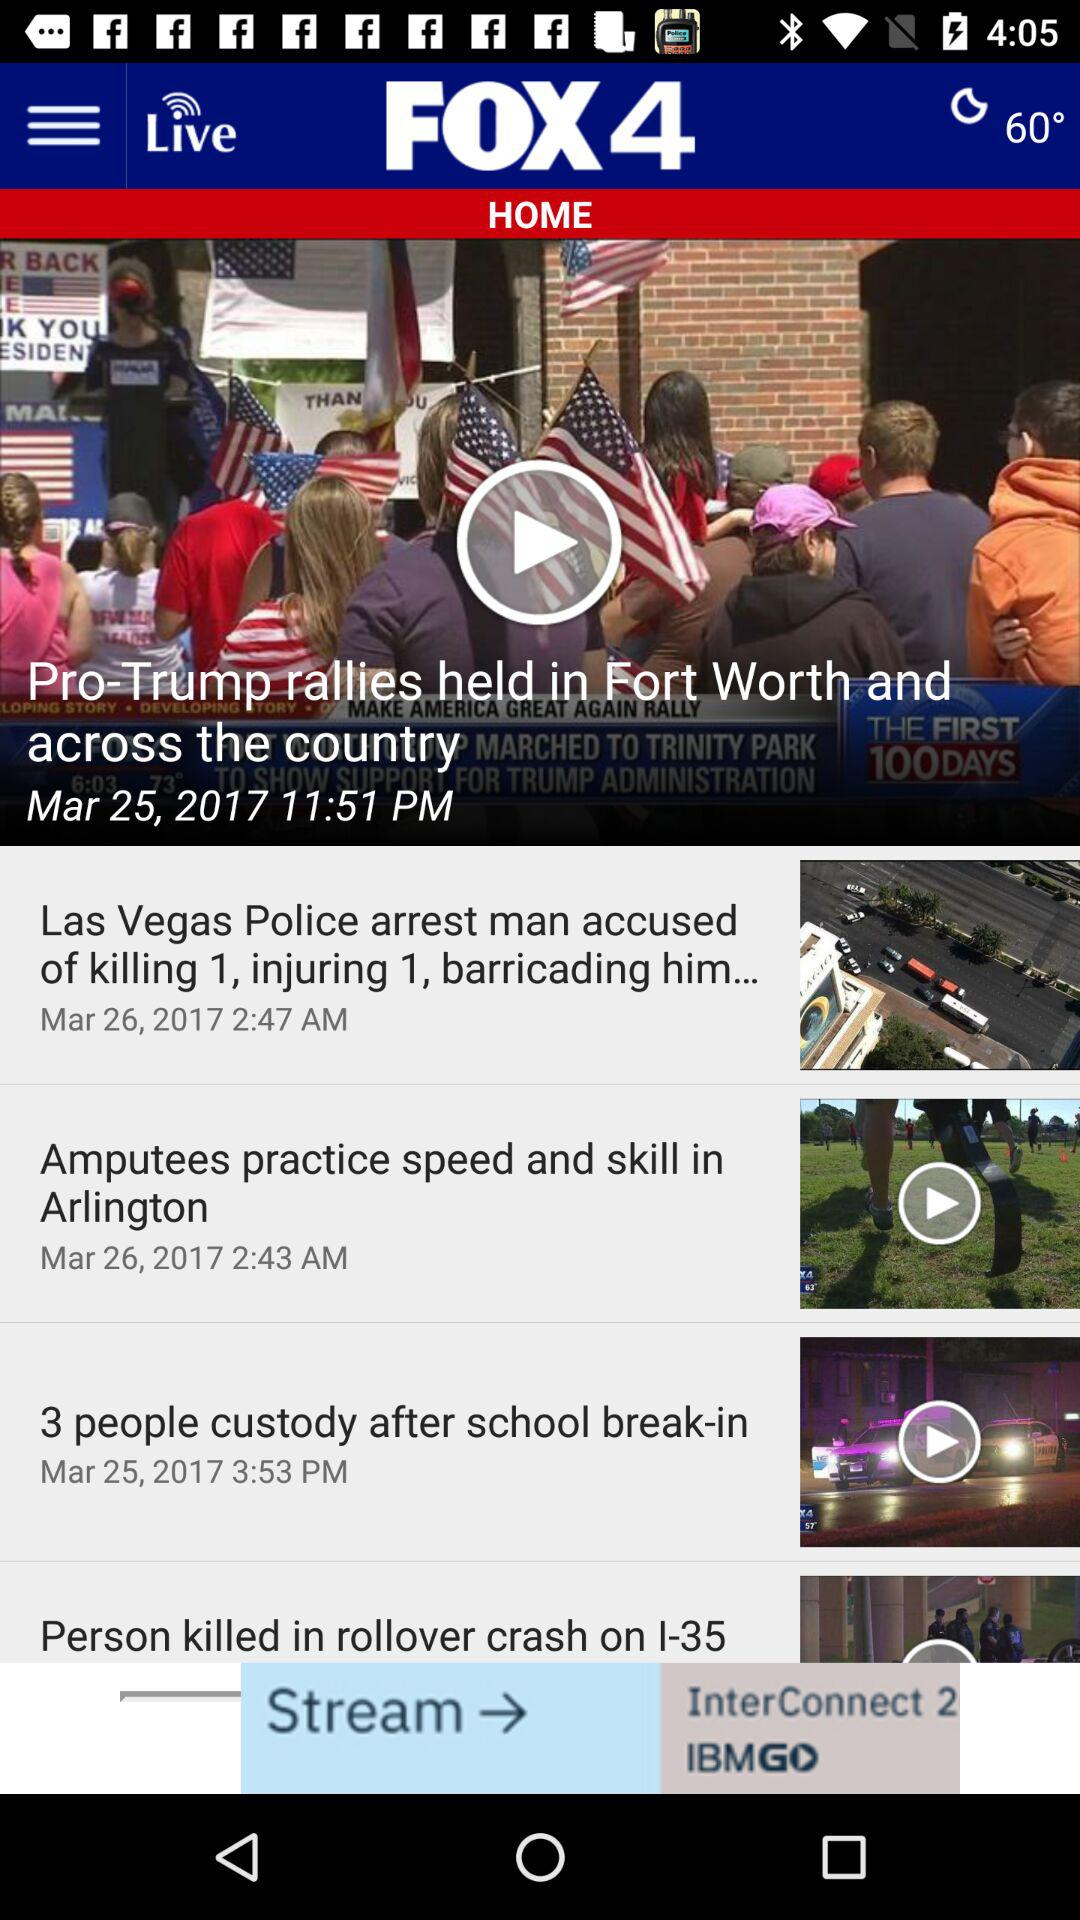What is the posted time and date of the news about Las Vegas police? The posted time and date of the news are 2:47 AM and March 26, 2017, respectively. 